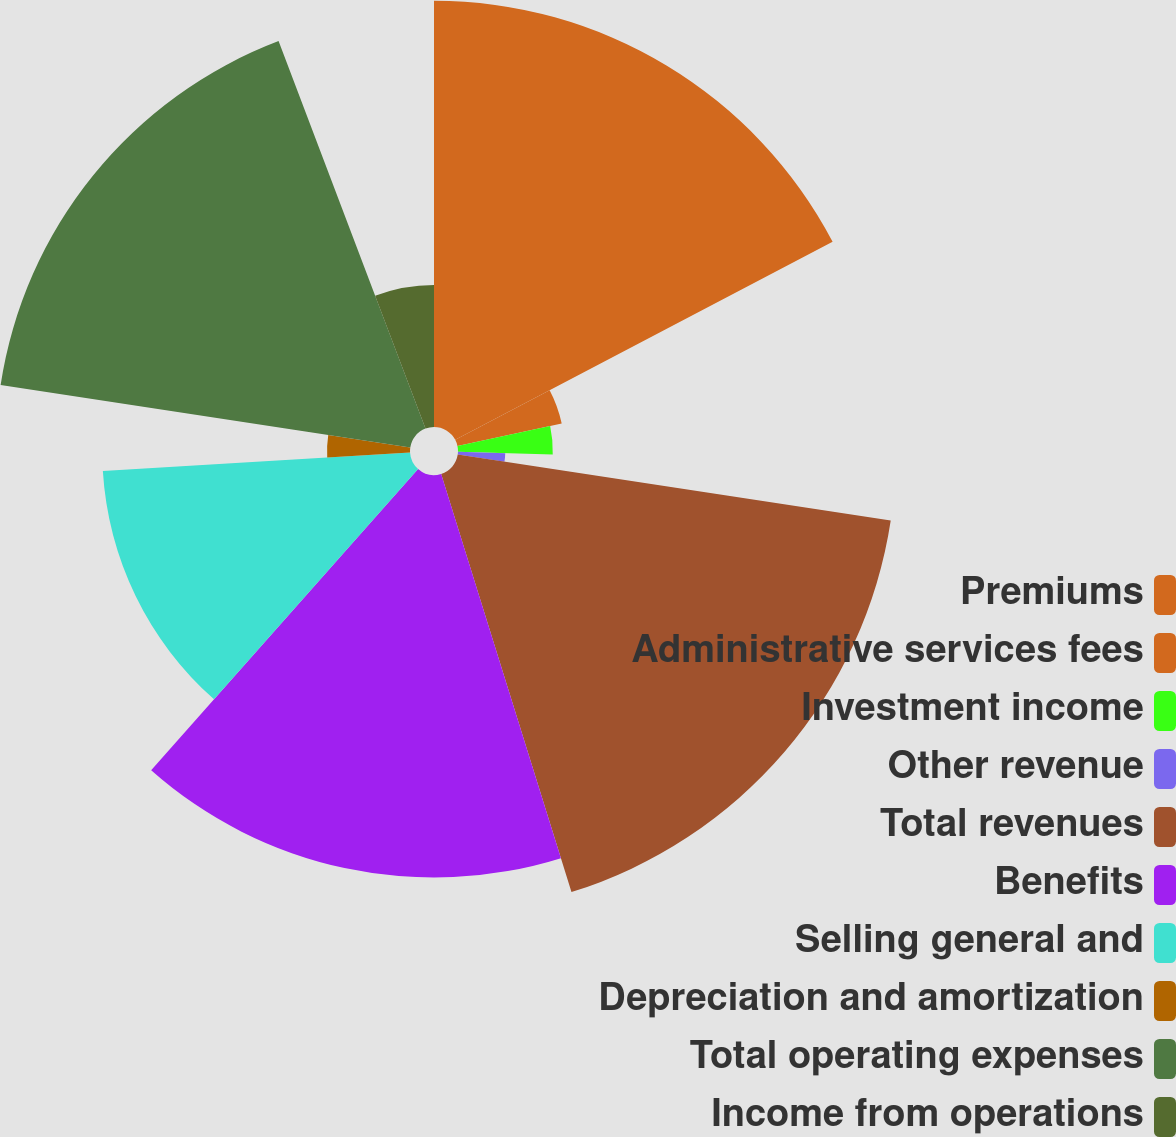Convert chart. <chart><loc_0><loc_0><loc_500><loc_500><pie_chart><fcel>Premiums<fcel>Administrative services fees<fcel>Investment income<fcel>Other revenue<fcel>Total revenues<fcel>Benefits<fcel>Selling general and<fcel>Depreciation and amortization<fcel>Total operating expenses<fcel>Income from operations<nl><fcel>17.31%<fcel>4.33%<fcel>3.85%<fcel>1.92%<fcel>17.79%<fcel>16.35%<fcel>12.5%<fcel>3.37%<fcel>16.83%<fcel>5.77%<nl></chart> 